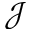Convert formula to latex. <formula><loc_0><loc_0><loc_500><loc_500>\mathcal { J }</formula> 